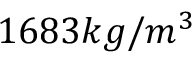<formula> <loc_0><loc_0><loc_500><loc_500>1 6 8 3 k g / m ^ { 3 }</formula> 